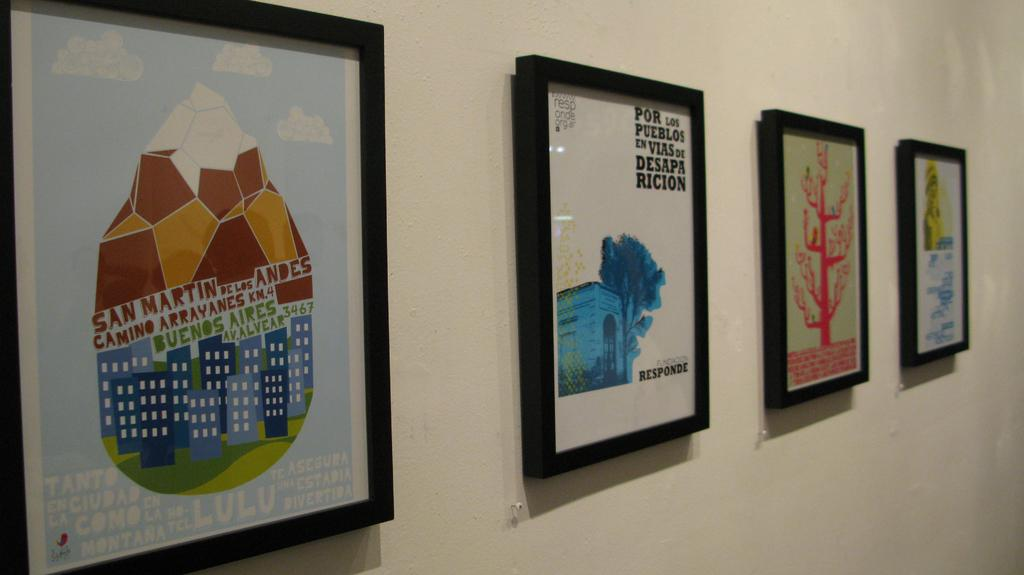<image>
Describe the image concisely. a few hanging items in the hall with one that has the word Ricion on it 